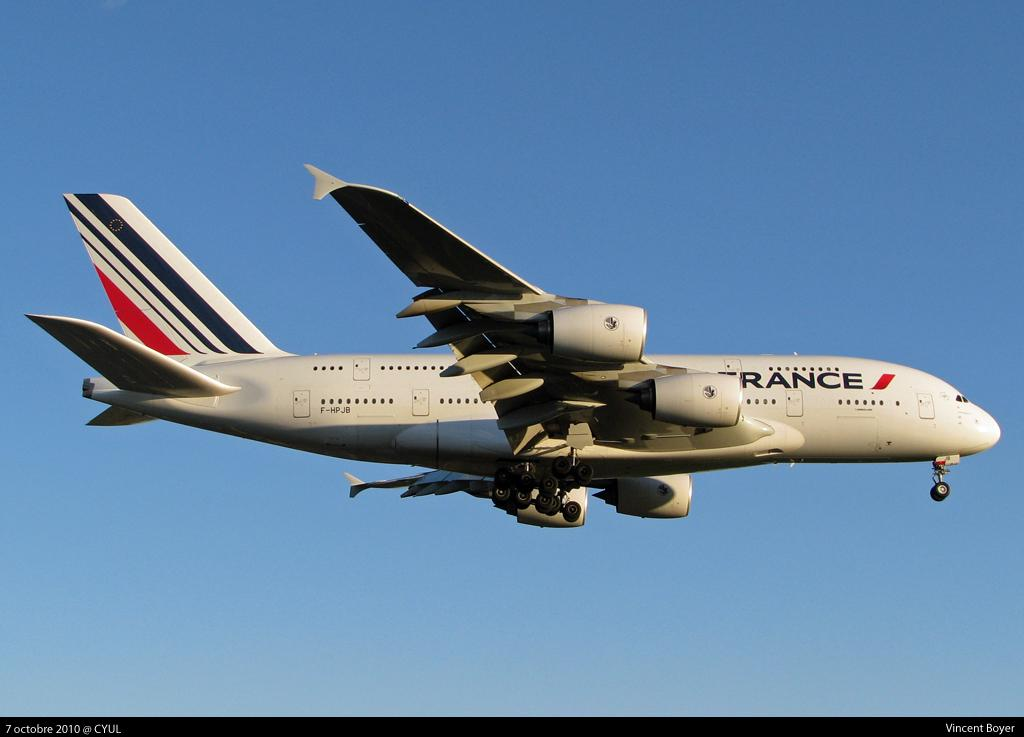<image>
Summarize the visual content of the image. a France plane is flying through a clear sky 